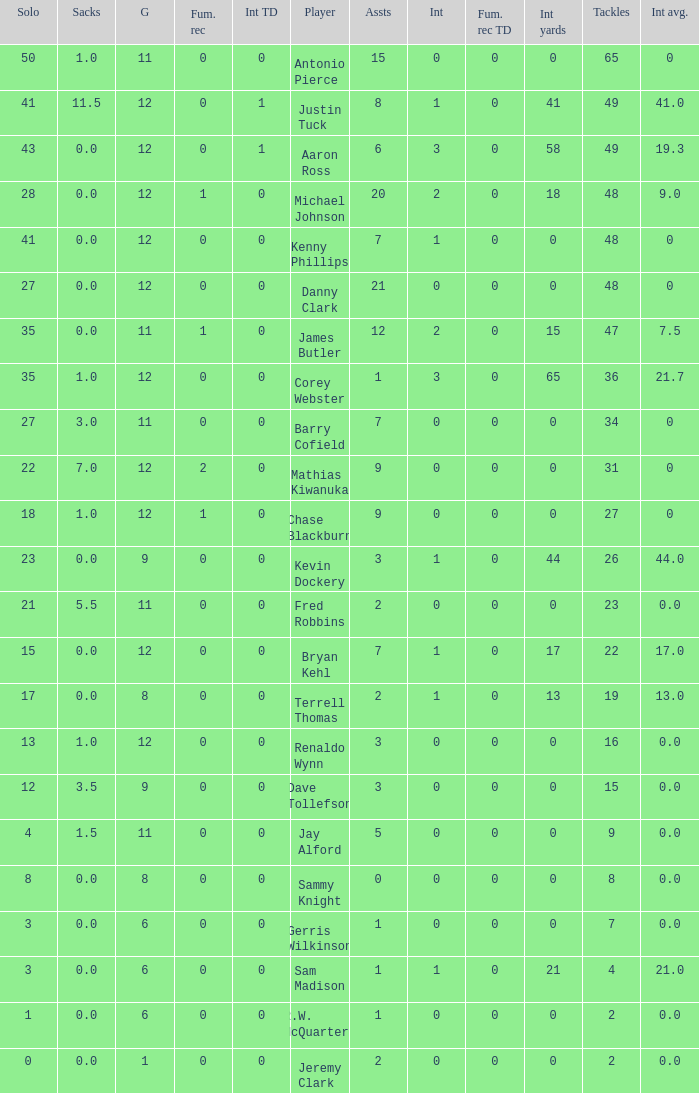Name the least amount of int yards 0.0. 